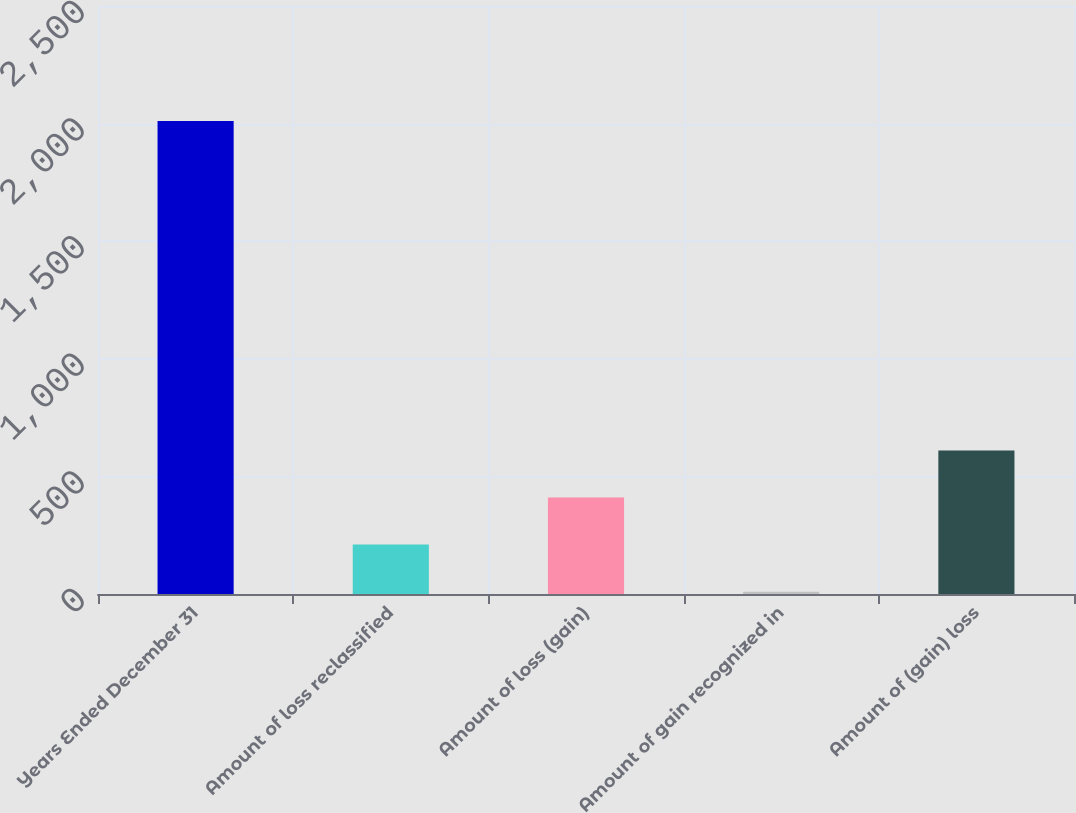Convert chart to OTSL. <chart><loc_0><loc_0><loc_500><loc_500><bar_chart><fcel>Years Ended December 31<fcel>Amount of loss reclassified<fcel>Amount of loss (gain)<fcel>Amount of gain recognized in<fcel>Amount of (gain) loss<nl><fcel>2011<fcel>210.1<fcel>410.2<fcel>10<fcel>610.3<nl></chart> 